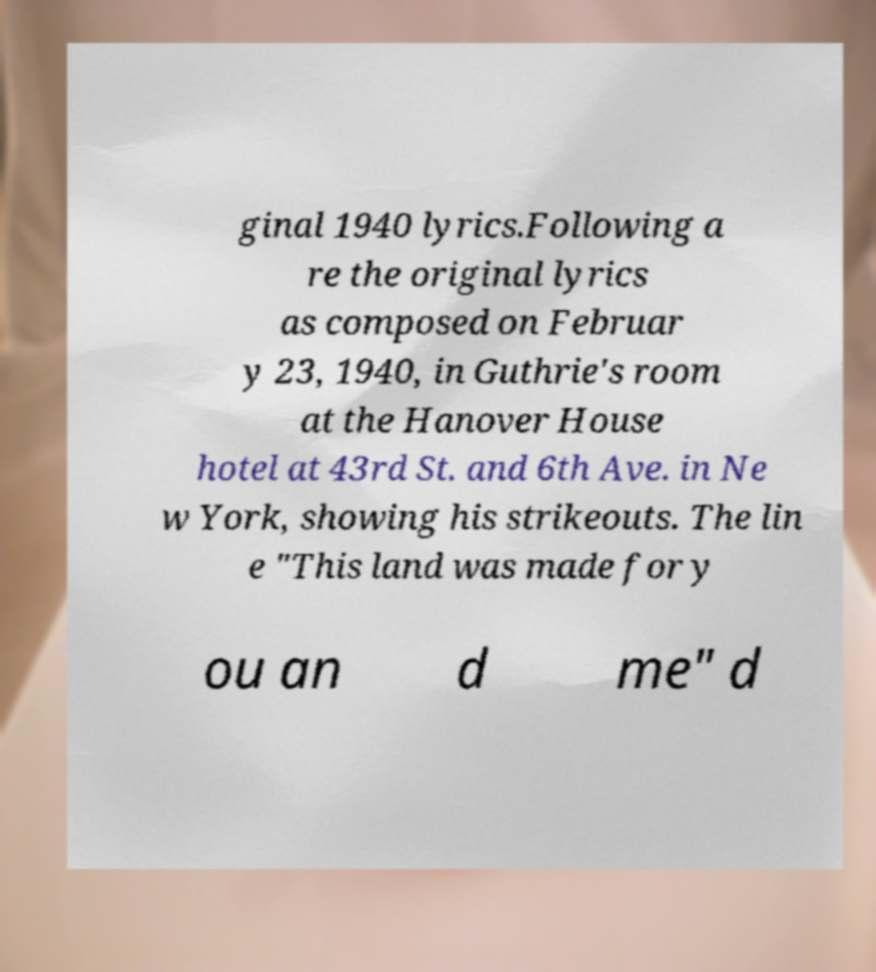Can you accurately transcribe the text from the provided image for me? ginal 1940 lyrics.Following a re the original lyrics as composed on Februar y 23, 1940, in Guthrie's room at the Hanover House hotel at 43rd St. and 6th Ave. in Ne w York, showing his strikeouts. The lin e "This land was made for y ou an d me" d 